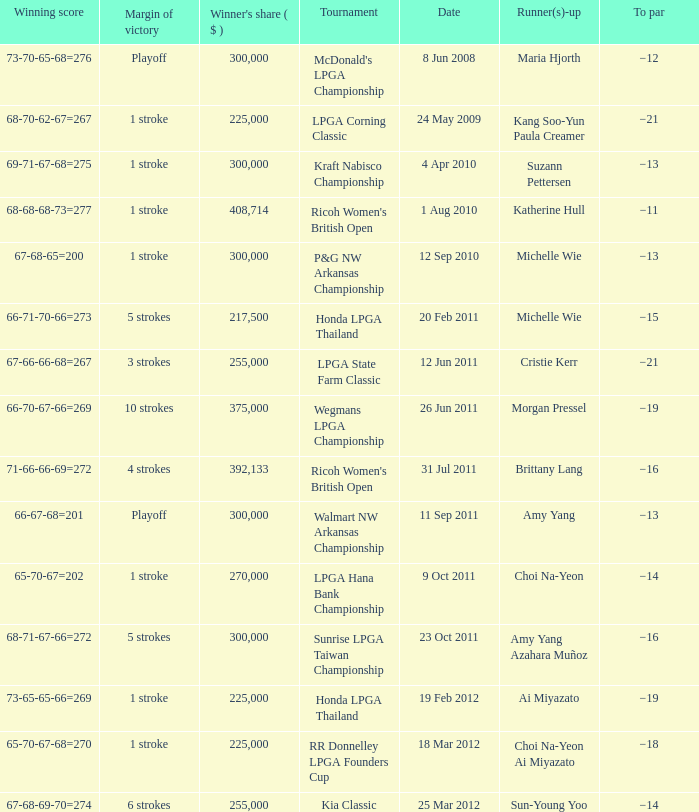Who was the runner-up in the RR Donnelley LPGA Founders Cup? Choi Na-Yeon Ai Miyazato. 